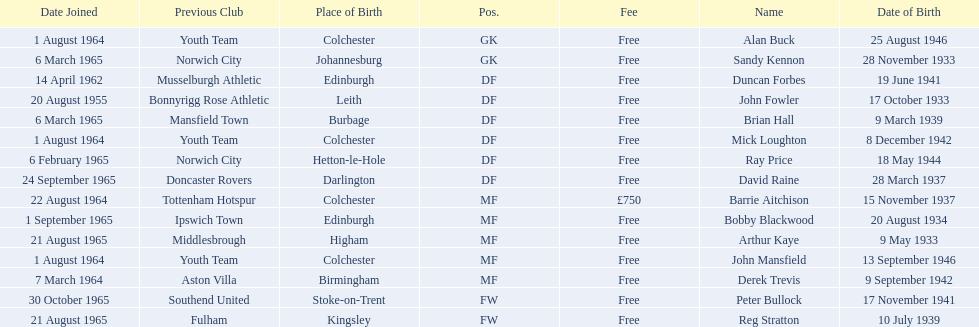Which player is the oldest? Arthur Kaye. 